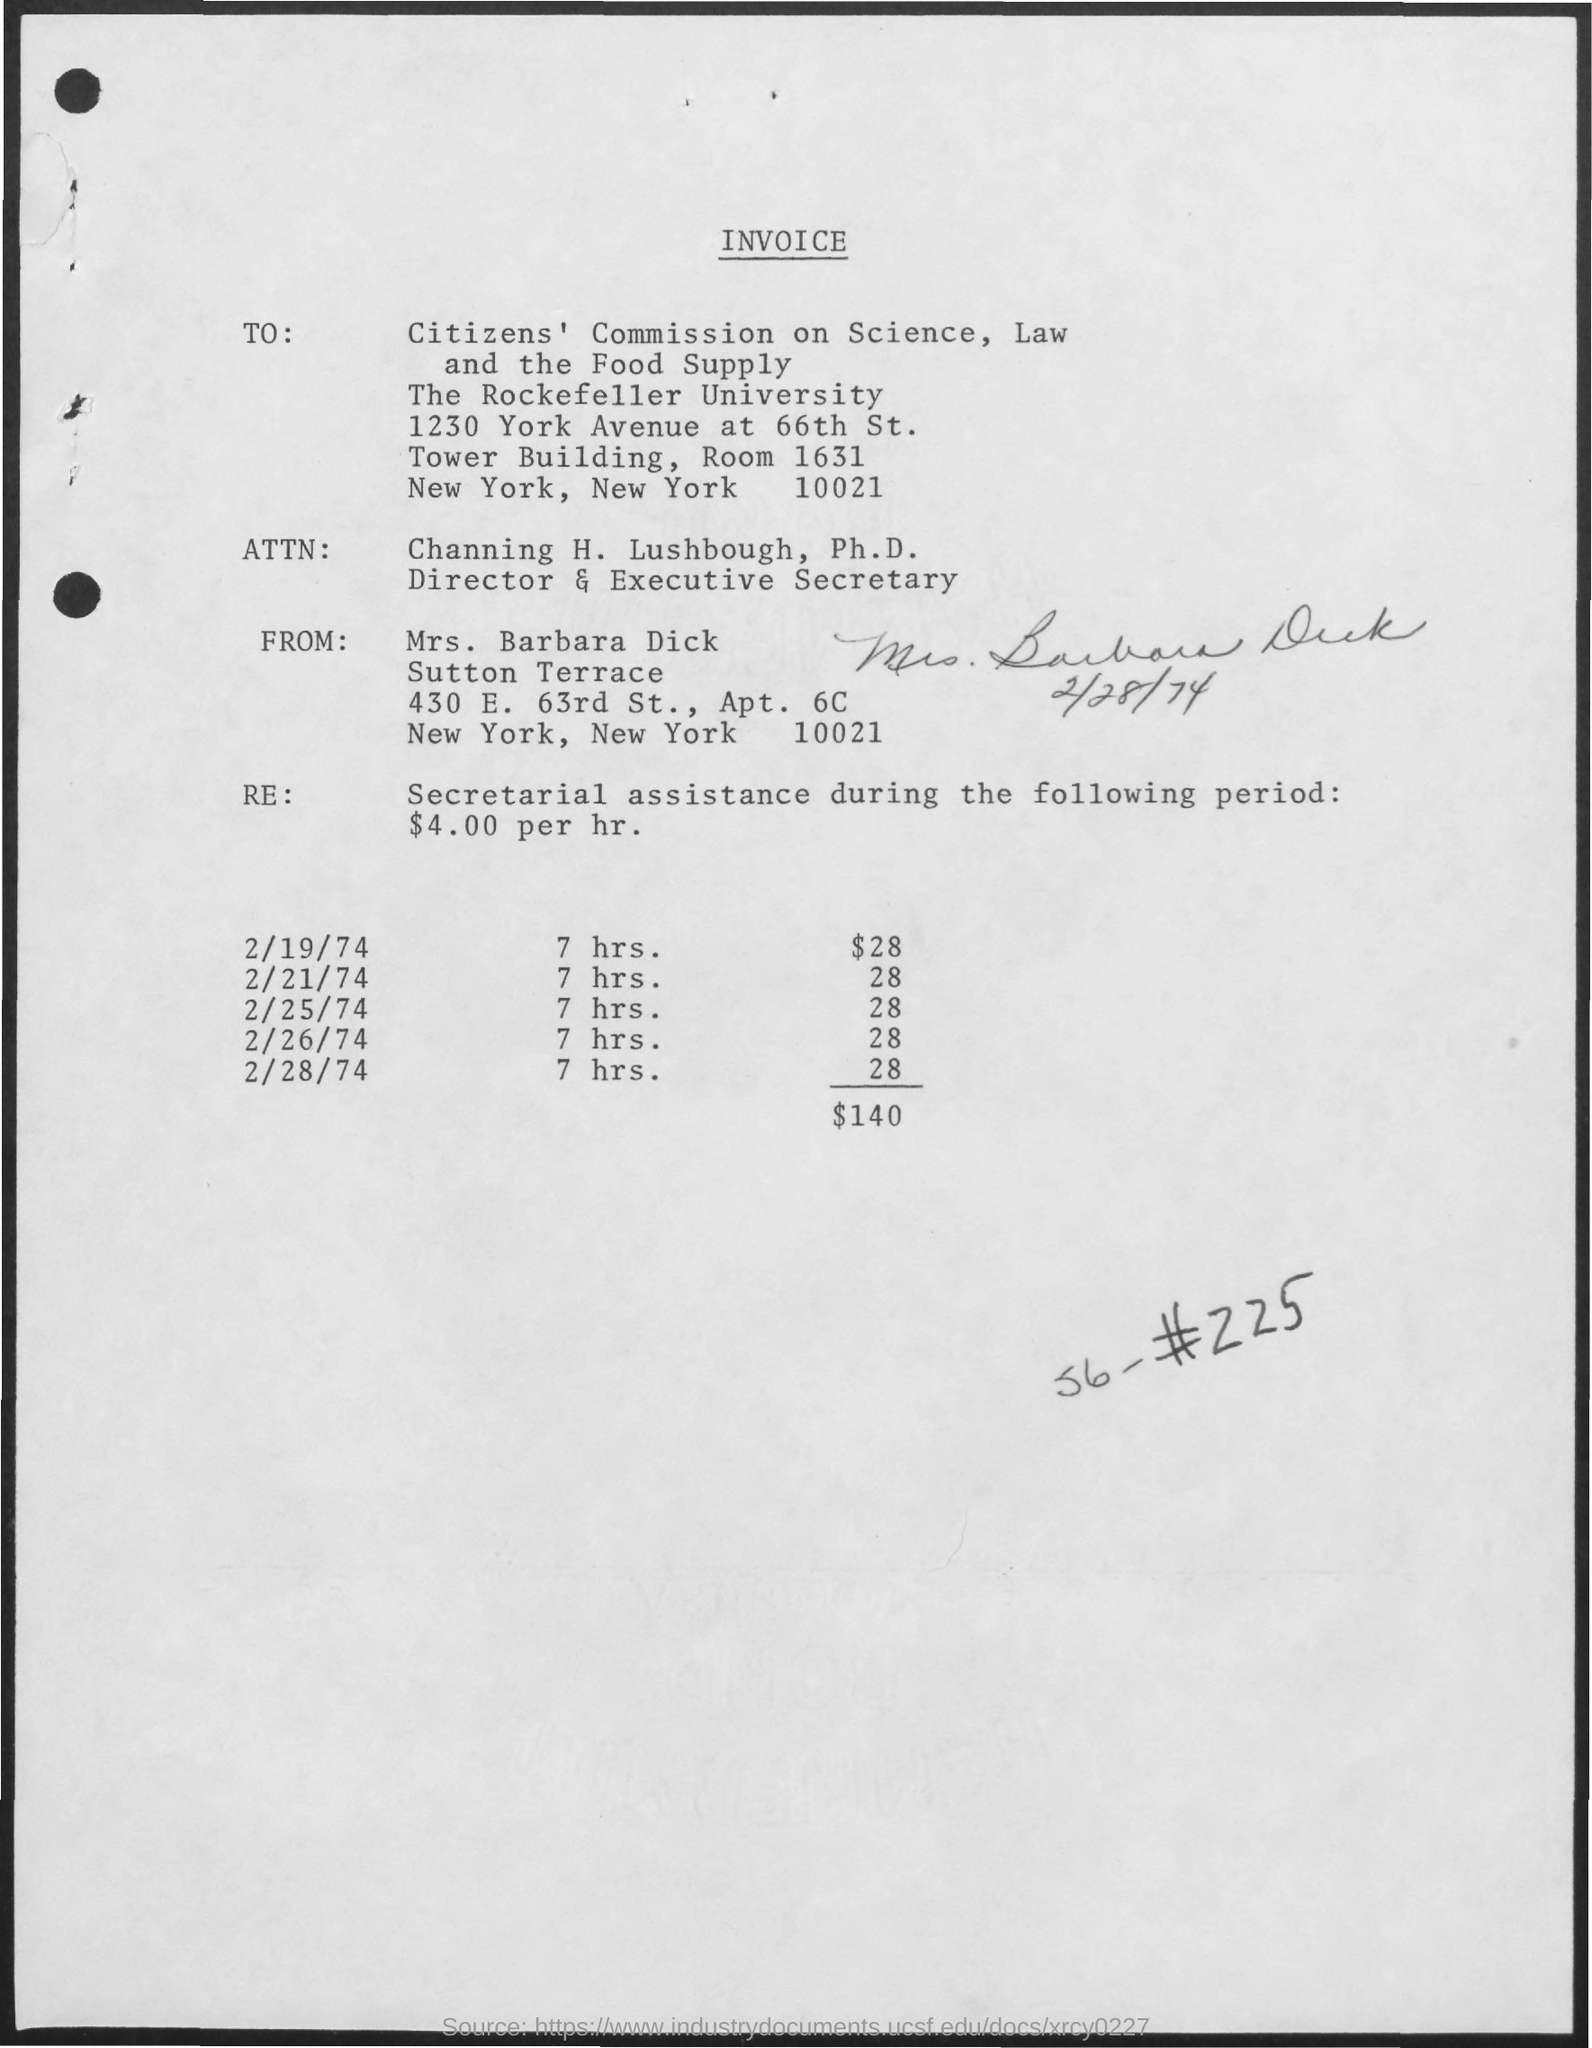Can you provide the date and the signature on the invoice? The date on the invoice is February 28, 1974, and it is signed by Mrs. Barbara Dick, with the signature appearing to be dated as well.  What are the specific dates of service noted on the invoice? The specific dates of service provided by Mrs. Barbara Dick are February 19, February 21, February 25, and February 28, 1974, each day accounting for 7 hours of work. 